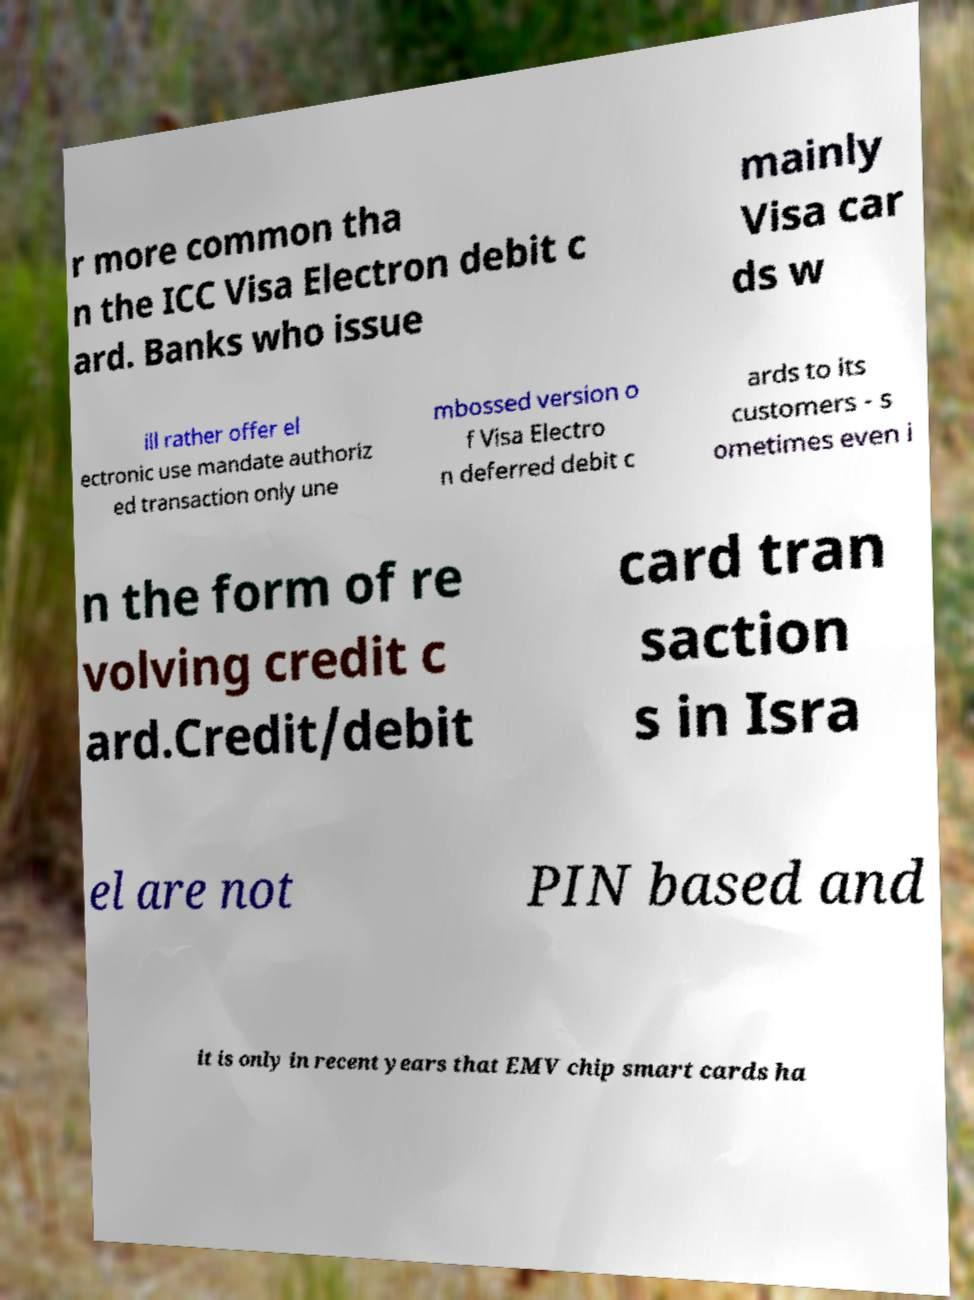Could you extract and type out the text from this image? r more common tha n the ICC Visa Electron debit c ard. Banks who issue mainly Visa car ds w ill rather offer el ectronic use mandate authoriz ed transaction only une mbossed version o f Visa Electro n deferred debit c ards to its customers - s ometimes even i n the form of re volving credit c ard.Credit/debit card tran saction s in Isra el are not PIN based and it is only in recent years that EMV chip smart cards ha 